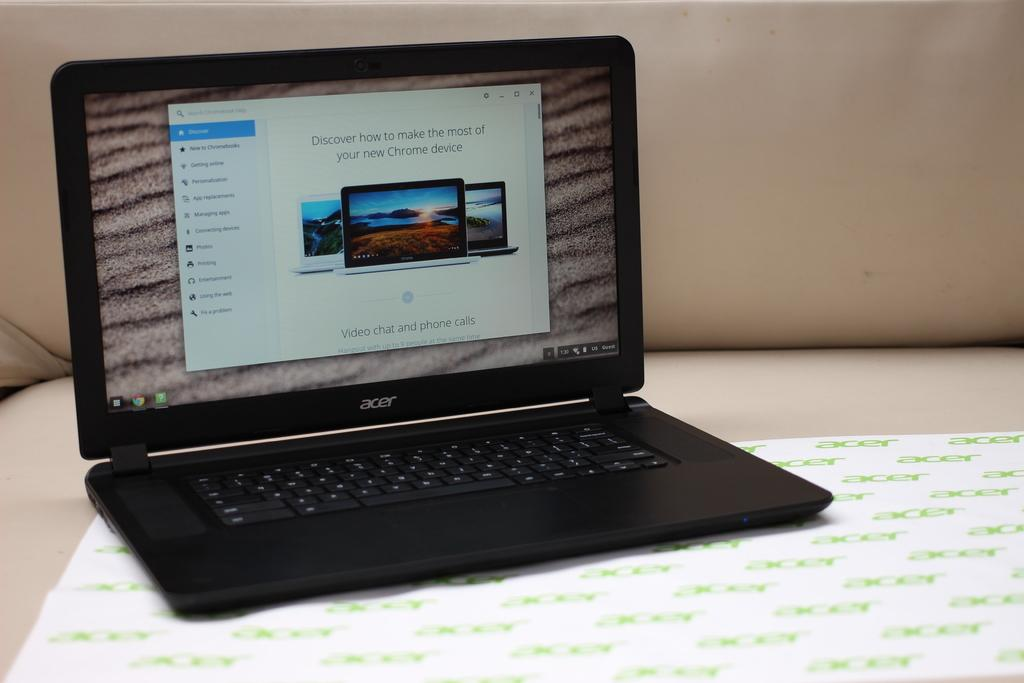<image>
Describe the image concisely. An acer laptop open to a web page inviting you to "Discover how to make the most of your new Chrome device". 